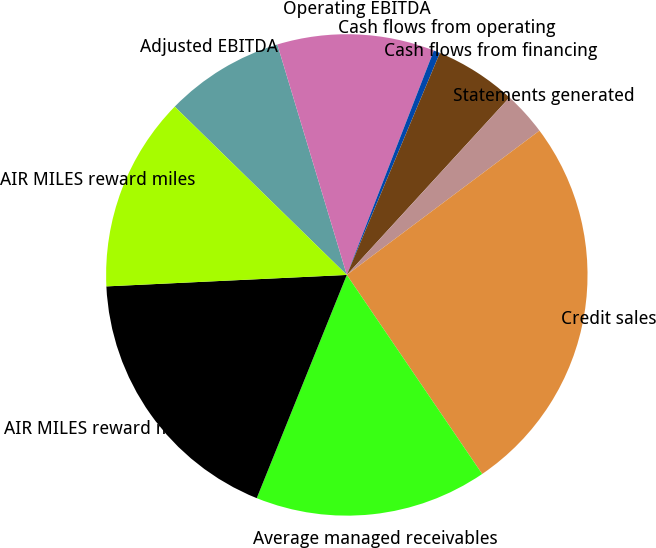Convert chart. <chart><loc_0><loc_0><loc_500><loc_500><pie_chart><fcel>Adjusted EBITDA<fcel>Operating EBITDA<fcel>Cash flows from operating<fcel>Cash flows from financing<fcel>Statements generated<fcel>Credit sales<fcel>Average managed receivables<fcel>AIR MILES reward miles issued<fcel>AIR MILES reward miles<nl><fcel>8.02%<fcel>10.55%<fcel>0.43%<fcel>5.49%<fcel>2.96%<fcel>25.73%<fcel>15.61%<fcel>18.14%<fcel>13.08%<nl></chart> 